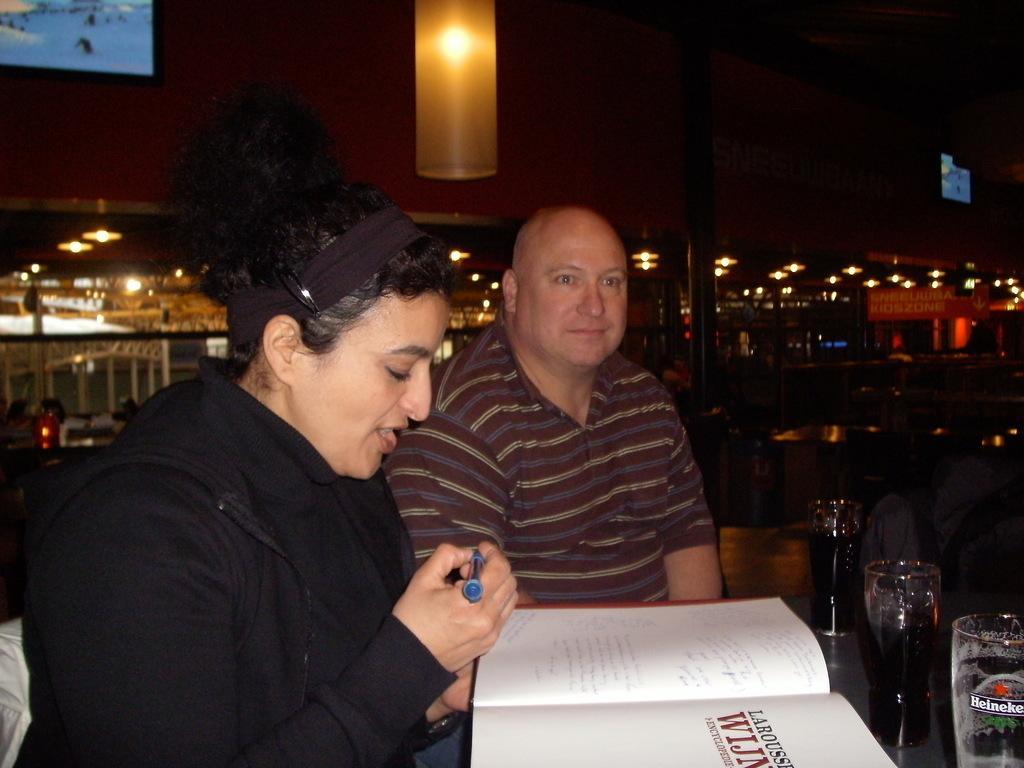Could you give a brief overview of what you see in this image? There are two people sitting and she is holding pen and book. We can see glasses on the surface. In the background we can see lights. 